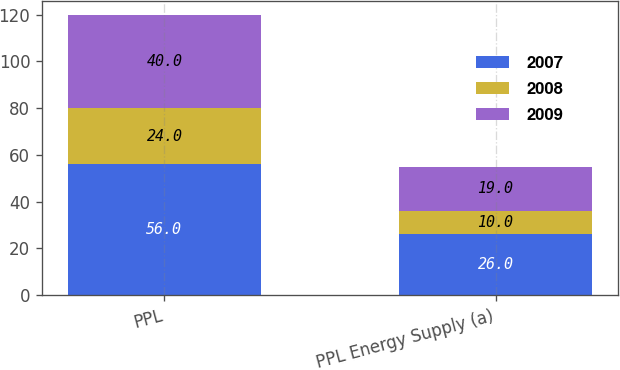<chart> <loc_0><loc_0><loc_500><loc_500><stacked_bar_chart><ecel><fcel>PPL<fcel>PPL Energy Supply (a)<nl><fcel>2007<fcel>56<fcel>26<nl><fcel>2008<fcel>24<fcel>10<nl><fcel>2009<fcel>40<fcel>19<nl></chart> 